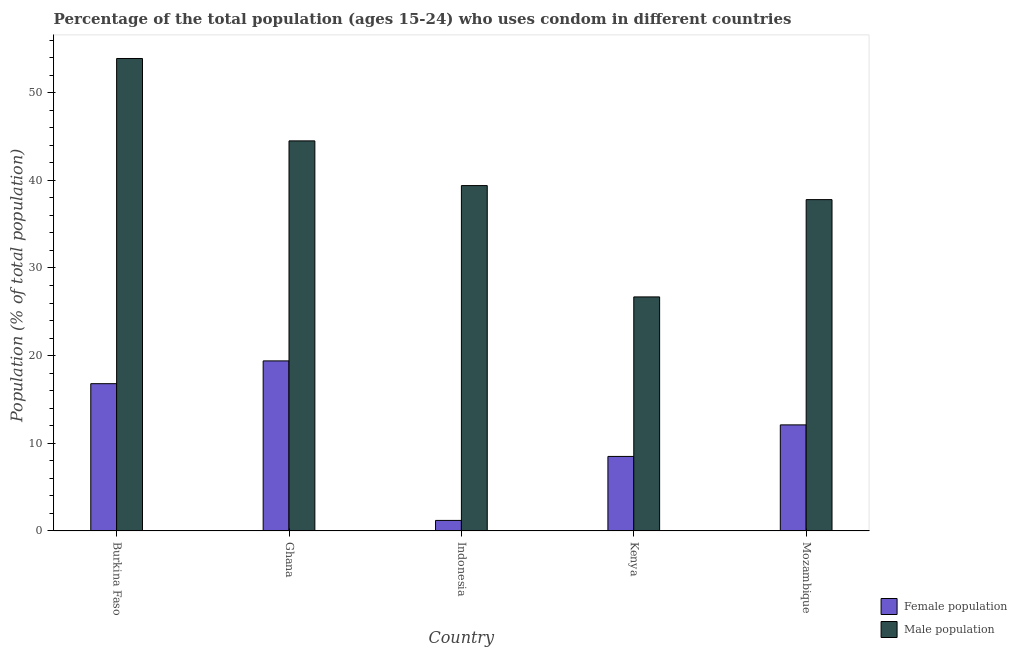How many groups of bars are there?
Provide a succinct answer. 5. What is the label of the 4th group of bars from the left?
Your answer should be very brief. Kenya. What is the male population in Burkina Faso?
Keep it short and to the point. 53.9. Across all countries, what is the maximum female population?
Ensure brevity in your answer.  19.4. Across all countries, what is the minimum male population?
Provide a succinct answer. 26.7. In which country was the male population minimum?
Your answer should be compact. Kenya. What is the total male population in the graph?
Offer a terse response. 202.3. What is the difference between the female population in Indonesia and that in Kenya?
Your answer should be compact. -7.3. What is the average female population per country?
Ensure brevity in your answer.  11.6. What is the difference between the female population and male population in Burkina Faso?
Keep it short and to the point. -37.1. What is the ratio of the female population in Burkina Faso to that in Ghana?
Make the answer very short. 0.87. Is the male population in Burkina Faso less than that in Indonesia?
Offer a very short reply. No. What is the difference between the highest and the second highest male population?
Offer a terse response. 9.4. What is the difference between the highest and the lowest female population?
Give a very brief answer. 18.2. In how many countries, is the male population greater than the average male population taken over all countries?
Your answer should be compact. 2. What does the 1st bar from the left in Kenya represents?
Your answer should be compact. Female population. What does the 2nd bar from the right in Ghana represents?
Provide a short and direct response. Female population. How many countries are there in the graph?
Make the answer very short. 5. What is the difference between two consecutive major ticks on the Y-axis?
Provide a short and direct response. 10. Does the graph contain any zero values?
Ensure brevity in your answer.  No. How are the legend labels stacked?
Offer a terse response. Vertical. What is the title of the graph?
Ensure brevity in your answer.  Percentage of the total population (ages 15-24) who uses condom in different countries. Does "International Visitors" appear as one of the legend labels in the graph?
Provide a succinct answer. No. What is the label or title of the X-axis?
Ensure brevity in your answer.  Country. What is the label or title of the Y-axis?
Keep it short and to the point. Population (% of total population) . What is the Population (% of total population)  in Female population in Burkina Faso?
Keep it short and to the point. 16.8. What is the Population (% of total population)  in Male population in Burkina Faso?
Your answer should be very brief. 53.9. What is the Population (% of total population)  in Female population in Ghana?
Provide a short and direct response. 19.4. What is the Population (% of total population)  of Male population in Ghana?
Your answer should be compact. 44.5. What is the Population (% of total population)  of Male population in Indonesia?
Offer a very short reply. 39.4. What is the Population (% of total population)  in Male population in Kenya?
Your answer should be very brief. 26.7. What is the Population (% of total population)  of Female population in Mozambique?
Ensure brevity in your answer.  12.1. What is the Population (% of total population)  of Male population in Mozambique?
Keep it short and to the point. 37.8. Across all countries, what is the maximum Population (% of total population)  in Male population?
Ensure brevity in your answer.  53.9. Across all countries, what is the minimum Population (% of total population)  in Female population?
Offer a very short reply. 1.2. Across all countries, what is the minimum Population (% of total population)  of Male population?
Ensure brevity in your answer.  26.7. What is the total Population (% of total population)  of Female population in the graph?
Provide a short and direct response. 58. What is the total Population (% of total population)  of Male population in the graph?
Offer a terse response. 202.3. What is the difference between the Population (% of total population)  of Male population in Burkina Faso and that in Ghana?
Offer a very short reply. 9.4. What is the difference between the Population (% of total population)  in Female population in Burkina Faso and that in Indonesia?
Give a very brief answer. 15.6. What is the difference between the Population (% of total population)  in Male population in Burkina Faso and that in Indonesia?
Your response must be concise. 14.5. What is the difference between the Population (% of total population)  of Male population in Burkina Faso and that in Kenya?
Make the answer very short. 27.2. What is the difference between the Population (% of total population)  of Female population in Indonesia and that in Kenya?
Offer a very short reply. -7.3. What is the difference between the Population (% of total population)  of Male population in Indonesia and that in Kenya?
Ensure brevity in your answer.  12.7. What is the difference between the Population (% of total population)  in Female population in Burkina Faso and the Population (% of total population)  in Male population in Ghana?
Give a very brief answer. -27.7. What is the difference between the Population (% of total population)  in Female population in Burkina Faso and the Population (% of total population)  in Male population in Indonesia?
Your answer should be compact. -22.6. What is the difference between the Population (% of total population)  of Female population in Burkina Faso and the Population (% of total population)  of Male population in Kenya?
Offer a terse response. -9.9. What is the difference between the Population (% of total population)  of Female population in Burkina Faso and the Population (% of total population)  of Male population in Mozambique?
Provide a succinct answer. -21. What is the difference between the Population (% of total population)  of Female population in Ghana and the Population (% of total population)  of Male population in Mozambique?
Give a very brief answer. -18.4. What is the difference between the Population (% of total population)  of Female population in Indonesia and the Population (% of total population)  of Male population in Kenya?
Offer a very short reply. -25.5. What is the difference between the Population (% of total population)  of Female population in Indonesia and the Population (% of total population)  of Male population in Mozambique?
Your response must be concise. -36.6. What is the difference between the Population (% of total population)  in Female population in Kenya and the Population (% of total population)  in Male population in Mozambique?
Offer a very short reply. -29.3. What is the average Population (% of total population)  of Female population per country?
Provide a succinct answer. 11.6. What is the average Population (% of total population)  of Male population per country?
Provide a short and direct response. 40.46. What is the difference between the Population (% of total population)  in Female population and Population (% of total population)  in Male population in Burkina Faso?
Your response must be concise. -37.1. What is the difference between the Population (% of total population)  of Female population and Population (% of total population)  of Male population in Ghana?
Provide a short and direct response. -25.1. What is the difference between the Population (% of total population)  in Female population and Population (% of total population)  in Male population in Indonesia?
Offer a very short reply. -38.2. What is the difference between the Population (% of total population)  in Female population and Population (% of total population)  in Male population in Kenya?
Your answer should be very brief. -18.2. What is the difference between the Population (% of total population)  in Female population and Population (% of total population)  in Male population in Mozambique?
Provide a succinct answer. -25.7. What is the ratio of the Population (% of total population)  in Female population in Burkina Faso to that in Ghana?
Offer a terse response. 0.87. What is the ratio of the Population (% of total population)  in Male population in Burkina Faso to that in Ghana?
Offer a very short reply. 1.21. What is the ratio of the Population (% of total population)  of Male population in Burkina Faso to that in Indonesia?
Offer a very short reply. 1.37. What is the ratio of the Population (% of total population)  of Female population in Burkina Faso to that in Kenya?
Your response must be concise. 1.98. What is the ratio of the Population (% of total population)  in Male population in Burkina Faso to that in Kenya?
Provide a succinct answer. 2.02. What is the ratio of the Population (% of total population)  in Female population in Burkina Faso to that in Mozambique?
Give a very brief answer. 1.39. What is the ratio of the Population (% of total population)  in Male population in Burkina Faso to that in Mozambique?
Your answer should be very brief. 1.43. What is the ratio of the Population (% of total population)  of Female population in Ghana to that in Indonesia?
Ensure brevity in your answer.  16.17. What is the ratio of the Population (% of total population)  in Male population in Ghana to that in Indonesia?
Give a very brief answer. 1.13. What is the ratio of the Population (% of total population)  of Female population in Ghana to that in Kenya?
Provide a short and direct response. 2.28. What is the ratio of the Population (% of total population)  in Female population in Ghana to that in Mozambique?
Provide a short and direct response. 1.6. What is the ratio of the Population (% of total population)  in Male population in Ghana to that in Mozambique?
Offer a very short reply. 1.18. What is the ratio of the Population (% of total population)  in Female population in Indonesia to that in Kenya?
Ensure brevity in your answer.  0.14. What is the ratio of the Population (% of total population)  of Male population in Indonesia to that in Kenya?
Your response must be concise. 1.48. What is the ratio of the Population (% of total population)  of Female population in Indonesia to that in Mozambique?
Your response must be concise. 0.1. What is the ratio of the Population (% of total population)  of Male population in Indonesia to that in Mozambique?
Offer a terse response. 1.04. What is the ratio of the Population (% of total population)  in Female population in Kenya to that in Mozambique?
Provide a succinct answer. 0.7. What is the ratio of the Population (% of total population)  of Male population in Kenya to that in Mozambique?
Keep it short and to the point. 0.71. What is the difference between the highest and the second highest Population (% of total population)  in Female population?
Offer a very short reply. 2.6. What is the difference between the highest and the lowest Population (% of total population)  of Female population?
Offer a terse response. 18.2. What is the difference between the highest and the lowest Population (% of total population)  of Male population?
Your answer should be very brief. 27.2. 